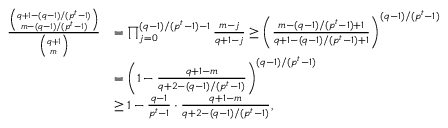<formula> <loc_0><loc_0><loc_500><loc_500>\begin{array} { r l } { \frac { \binom { q + 1 - ( q - 1 ) / ( p ^ { t } - 1 ) } { m - ( q - 1 ) / ( p ^ { t } - 1 ) } } { \binom { q + 1 } { m } } } & { = \prod _ { j = 0 } ^ { ( q - 1 ) / ( p ^ { t } - 1 ) - 1 } \frac { m - j } { q + 1 - j } \geq \left ( \frac { m - ( q - 1 ) / ( p ^ { t } - 1 ) + 1 } { q + 1 - ( q - 1 ) / ( p ^ { t } - 1 ) + 1 } \right ) ^ { ( q - 1 ) / ( p ^ { t } - 1 ) } } \\ & { = \left ( 1 - \frac { q + 1 - m } { q + 2 - ( q - 1 ) / ( p ^ { t } - 1 ) } \right ) ^ { ( q - 1 ) / ( p ^ { t } - 1 ) } } \\ & { \geq 1 - \frac { q - 1 } { p ^ { t } - 1 } \cdot \frac { q + 1 - m } { q + 2 - ( q - 1 ) / ( p ^ { t } - 1 ) } , } \end{array}</formula> 